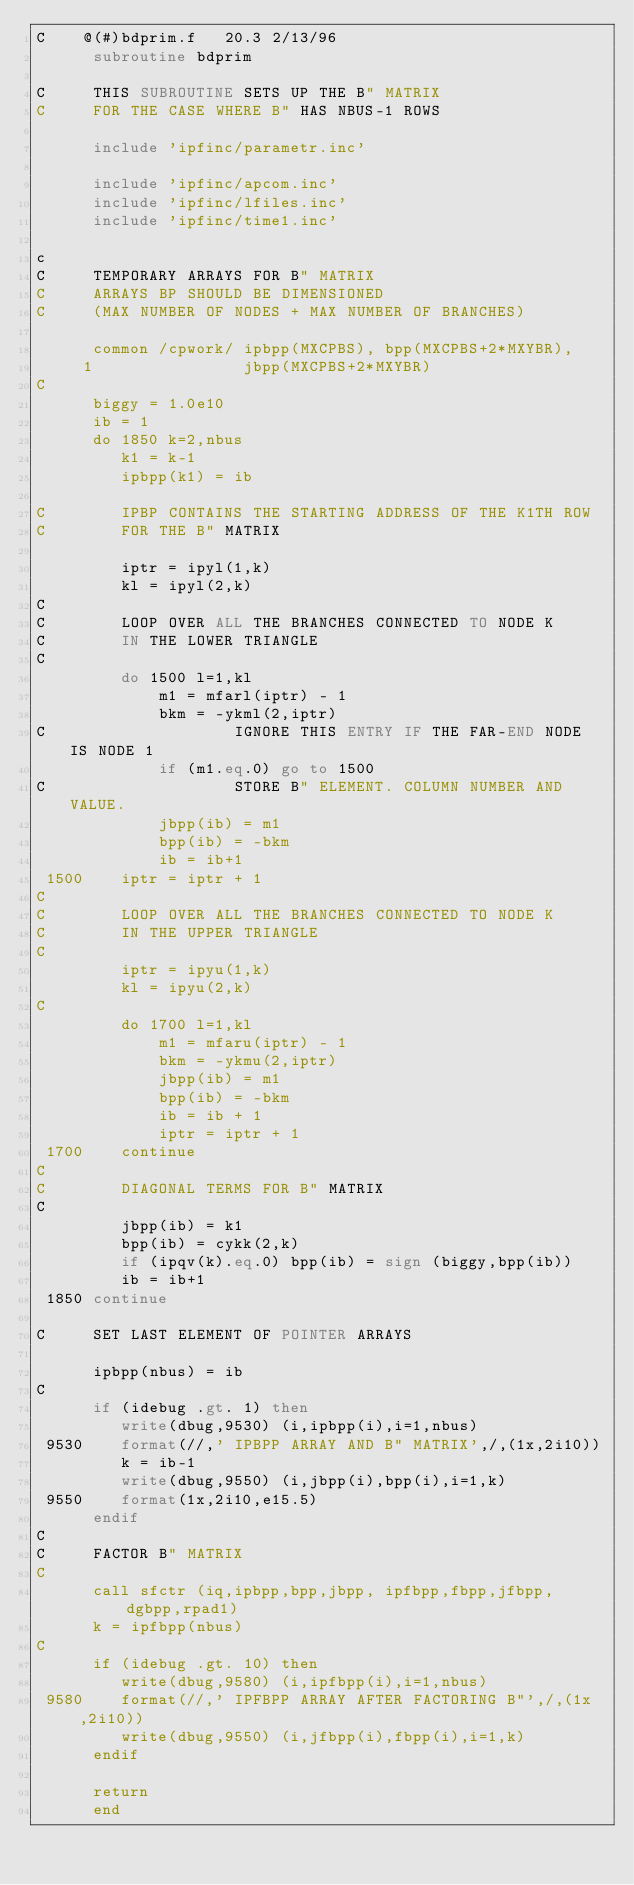<code> <loc_0><loc_0><loc_500><loc_500><_FORTRAN_>C    @(#)bdprim.f	20.3 2/13/96
      subroutine bdprim

C     THIS SUBROUTINE SETS UP THE B" MATRIX
C     FOR THE CASE WHERE B" HAS NBUS-1 ROWS
 
      include 'ipfinc/parametr.inc'

      include 'ipfinc/apcom.inc'
      include 'ipfinc/lfiles.inc'
      include 'ipfinc/time1.inc'
 
c
C     TEMPORARY ARRAYS FOR B" MATRIX
C     ARRAYS BP SHOULD BE DIMENSIONED
C     (MAX NUMBER OF NODES + MAX NUMBER OF BRANCHES)
 
      common /cpwork/ ipbpp(MXCPBS), bpp(MXCPBS+2*MXYBR),
     1                jbpp(MXCPBS+2*MXYBR)
C
      biggy = 1.0e10
      ib = 1
      do 1850 k=2,nbus
         k1 = k-1
         ipbpp(k1) = ib
 
C        IPBP CONTAINS THE STARTING ADDRESS OF THE K1TH ROW
C        FOR THE B" MATRIX

         iptr = ipyl(1,k)
         kl = ipyl(2,k)
C
C        LOOP OVER ALL THE BRANCHES CONNECTED TO NODE K
C        IN THE LOWER TRIANGLE
C
         do 1500 l=1,kl
             m1 = mfarl(iptr) - 1
             bkm = -ykml(2,iptr)
C                    IGNORE THIS ENTRY IF THE FAR-END NODE IS NODE 1
             if (m1.eq.0) go to 1500
C                    STORE B" ELEMENT. COLUMN NUMBER AND VALUE.
             jbpp(ib) = m1
             bpp(ib) = -bkm
             ib = ib+1
 1500    iptr = iptr + 1
C
C        LOOP OVER ALL THE BRANCHES CONNECTED TO NODE K
C        IN THE UPPER TRIANGLE
C
         iptr = ipyu(1,k)
         kl = ipyu(2,k)
C
         do 1700 l=1,kl
             m1 = mfaru(iptr) - 1
             bkm = -ykmu(2,iptr)
             jbpp(ib) = m1
             bpp(ib) = -bkm
             ib = ib + 1
             iptr = iptr + 1
 1700    continue
C
C        DIAGONAL TERMS FOR B" MATRIX
C
         jbpp(ib) = k1
         bpp(ib) = cykk(2,k)
         if (ipqv(k).eq.0) bpp(ib) = sign (biggy,bpp(ib))
         ib = ib+1
 1850 continue

C     SET LAST ELEMENT OF POINTER ARRAYS

      ipbpp(nbus) = ib
C
      if (idebug .gt. 1) then
         write(dbug,9530) (i,ipbpp(i),i=1,nbus)
 9530    format(//,' IPBPP ARRAY AND B" MATRIX',/,(1x,2i10))
         k = ib-1
         write(dbug,9550) (i,jbpp(i),bpp(i),i=1,k)
 9550    format(1x,2i10,e15.5)
      endif
C
C     FACTOR B" MATRIX
C
      call sfctr (iq,ipbpp,bpp,jbpp, ipfbpp,fbpp,jfbpp, dgbpp,rpad1)
      k = ipfbpp(nbus)
C
      if (idebug .gt. 10) then
         write(dbug,9580) (i,ipfbpp(i),i=1,nbus)
 9580    format(//,' IPFBPP ARRAY AFTER FACTORING B"',/,(1x,2i10))
         write(dbug,9550) (i,jfbpp(i),fbpp(i),i=1,k)
      endif

      return
      end
</code> 